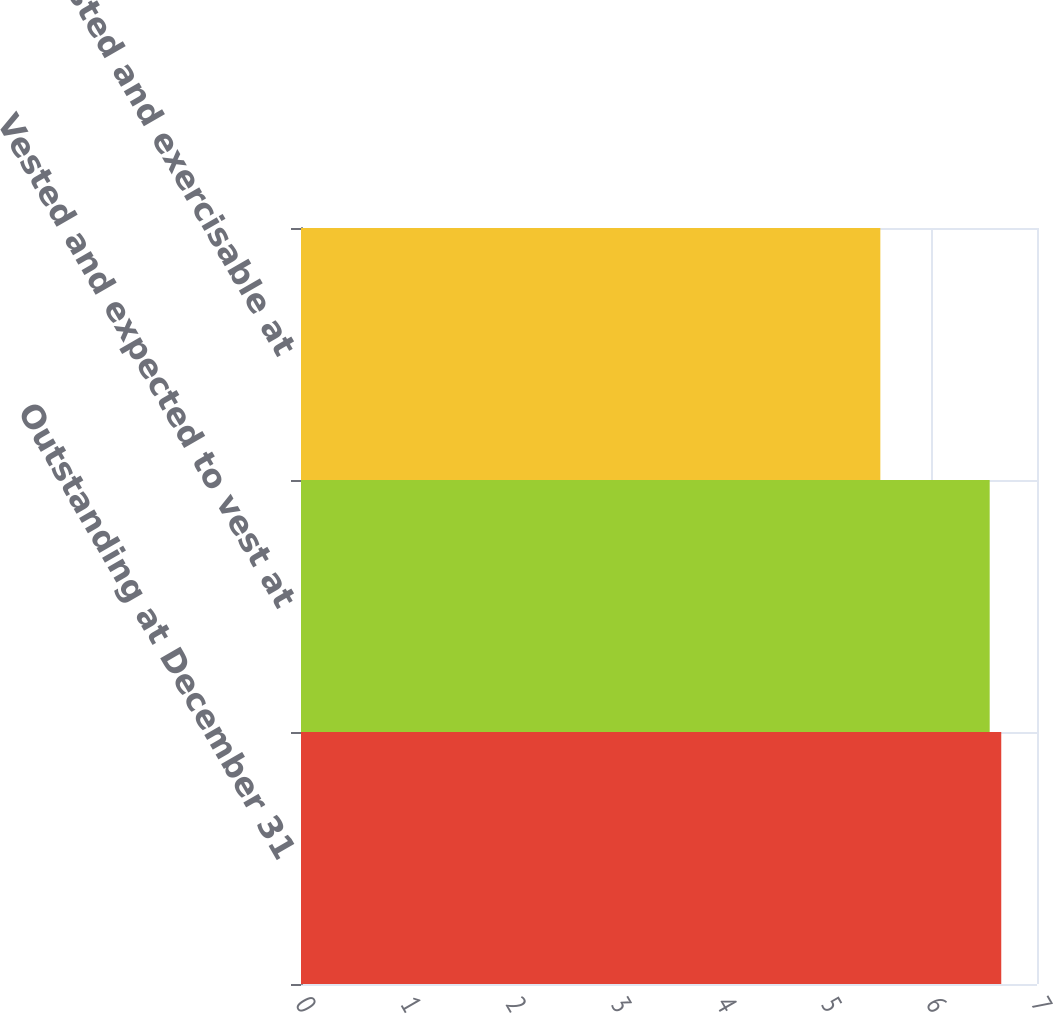<chart> <loc_0><loc_0><loc_500><loc_500><bar_chart><fcel>Outstanding at December 31<fcel>Vested and expected to vest at<fcel>Vested and exercisable at<nl><fcel>6.66<fcel>6.55<fcel>5.51<nl></chart> 